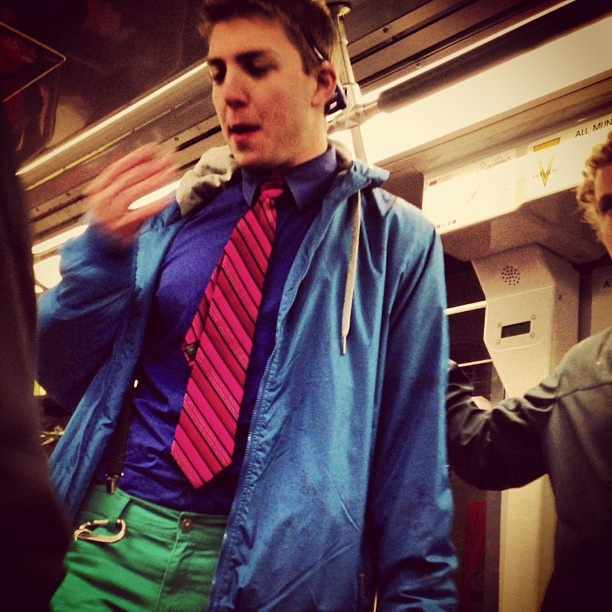Describe the objects in this image and their specific colors. I can see people in black, navy, and gray tones, people in black, maroon, gray, and tan tones, people in black, maroon, darkgreen, and navy tones, and tie in black, brown, and maroon tones in this image. 